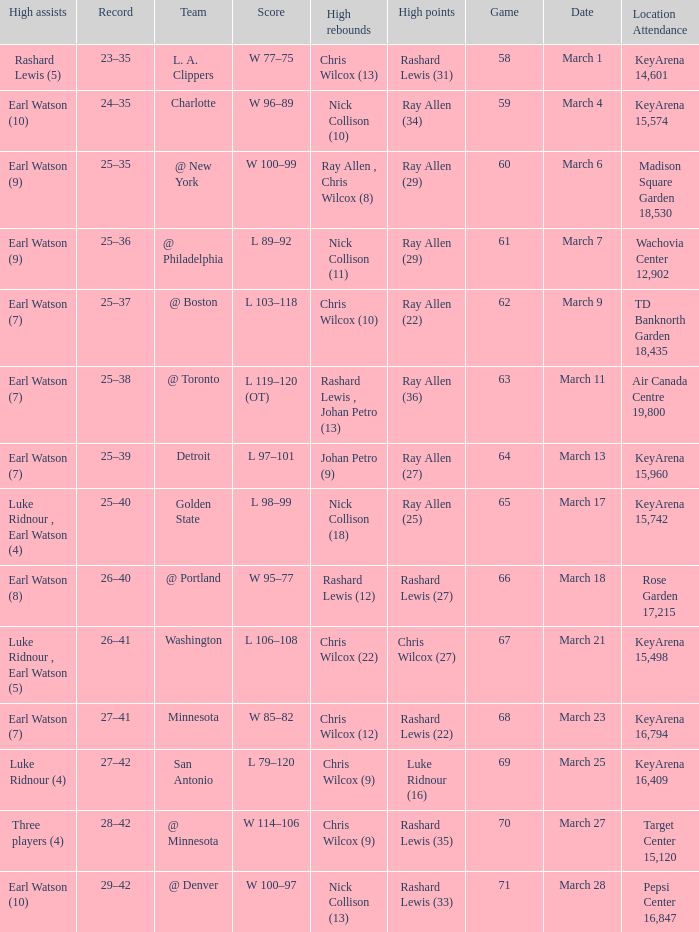Who had the most points in the game on March 7? Ray Allen (29). Give me the full table as a dictionary. {'header': ['High assists', 'Record', 'Team', 'Score', 'High rebounds', 'High points', 'Game', 'Date', 'Location Attendance'], 'rows': [['Rashard Lewis (5)', '23–35', 'L. A. Clippers', 'W 77–75', 'Chris Wilcox (13)', 'Rashard Lewis (31)', '58', 'March 1', 'KeyArena 14,601'], ['Earl Watson (10)', '24–35', 'Charlotte', 'W 96–89', 'Nick Collison (10)', 'Ray Allen (34)', '59', 'March 4', 'KeyArena 15,574'], ['Earl Watson (9)', '25–35', '@ New York', 'W 100–99', 'Ray Allen , Chris Wilcox (8)', 'Ray Allen (29)', '60', 'March 6', 'Madison Square Garden 18,530'], ['Earl Watson (9)', '25–36', '@ Philadelphia', 'L 89–92', 'Nick Collison (11)', 'Ray Allen (29)', '61', 'March 7', 'Wachovia Center 12,902'], ['Earl Watson (7)', '25–37', '@ Boston', 'L 103–118', 'Chris Wilcox (10)', 'Ray Allen (22)', '62', 'March 9', 'TD Banknorth Garden 18,435'], ['Earl Watson (7)', '25–38', '@ Toronto', 'L 119–120 (OT)', 'Rashard Lewis , Johan Petro (13)', 'Ray Allen (36)', '63', 'March 11', 'Air Canada Centre 19,800'], ['Earl Watson (7)', '25–39', 'Detroit', 'L 97–101', 'Johan Petro (9)', 'Ray Allen (27)', '64', 'March 13', 'KeyArena 15,960'], ['Luke Ridnour , Earl Watson (4)', '25–40', 'Golden State', 'L 98–99', 'Nick Collison (18)', 'Ray Allen (25)', '65', 'March 17', 'KeyArena 15,742'], ['Earl Watson (8)', '26–40', '@ Portland', 'W 95–77', 'Rashard Lewis (12)', 'Rashard Lewis (27)', '66', 'March 18', 'Rose Garden 17,215'], ['Luke Ridnour , Earl Watson (5)', '26–41', 'Washington', 'L 106–108', 'Chris Wilcox (22)', 'Chris Wilcox (27)', '67', 'March 21', 'KeyArena 15,498'], ['Earl Watson (7)', '27–41', 'Minnesota', 'W 85–82', 'Chris Wilcox (12)', 'Rashard Lewis (22)', '68', 'March 23', 'KeyArena 16,794'], ['Luke Ridnour (4)', '27–42', 'San Antonio', 'L 79–120', 'Chris Wilcox (9)', 'Luke Ridnour (16)', '69', 'March 25', 'KeyArena 16,409'], ['Three players (4)', '28–42', '@ Minnesota', 'W 114–106', 'Chris Wilcox (9)', 'Rashard Lewis (35)', '70', 'March 27', 'Target Center 15,120'], ['Earl Watson (10)', '29–42', '@ Denver', 'W 100–97', 'Nick Collison (13)', 'Rashard Lewis (33)', '71', 'March 28', 'Pepsi Center 16,847']]} 